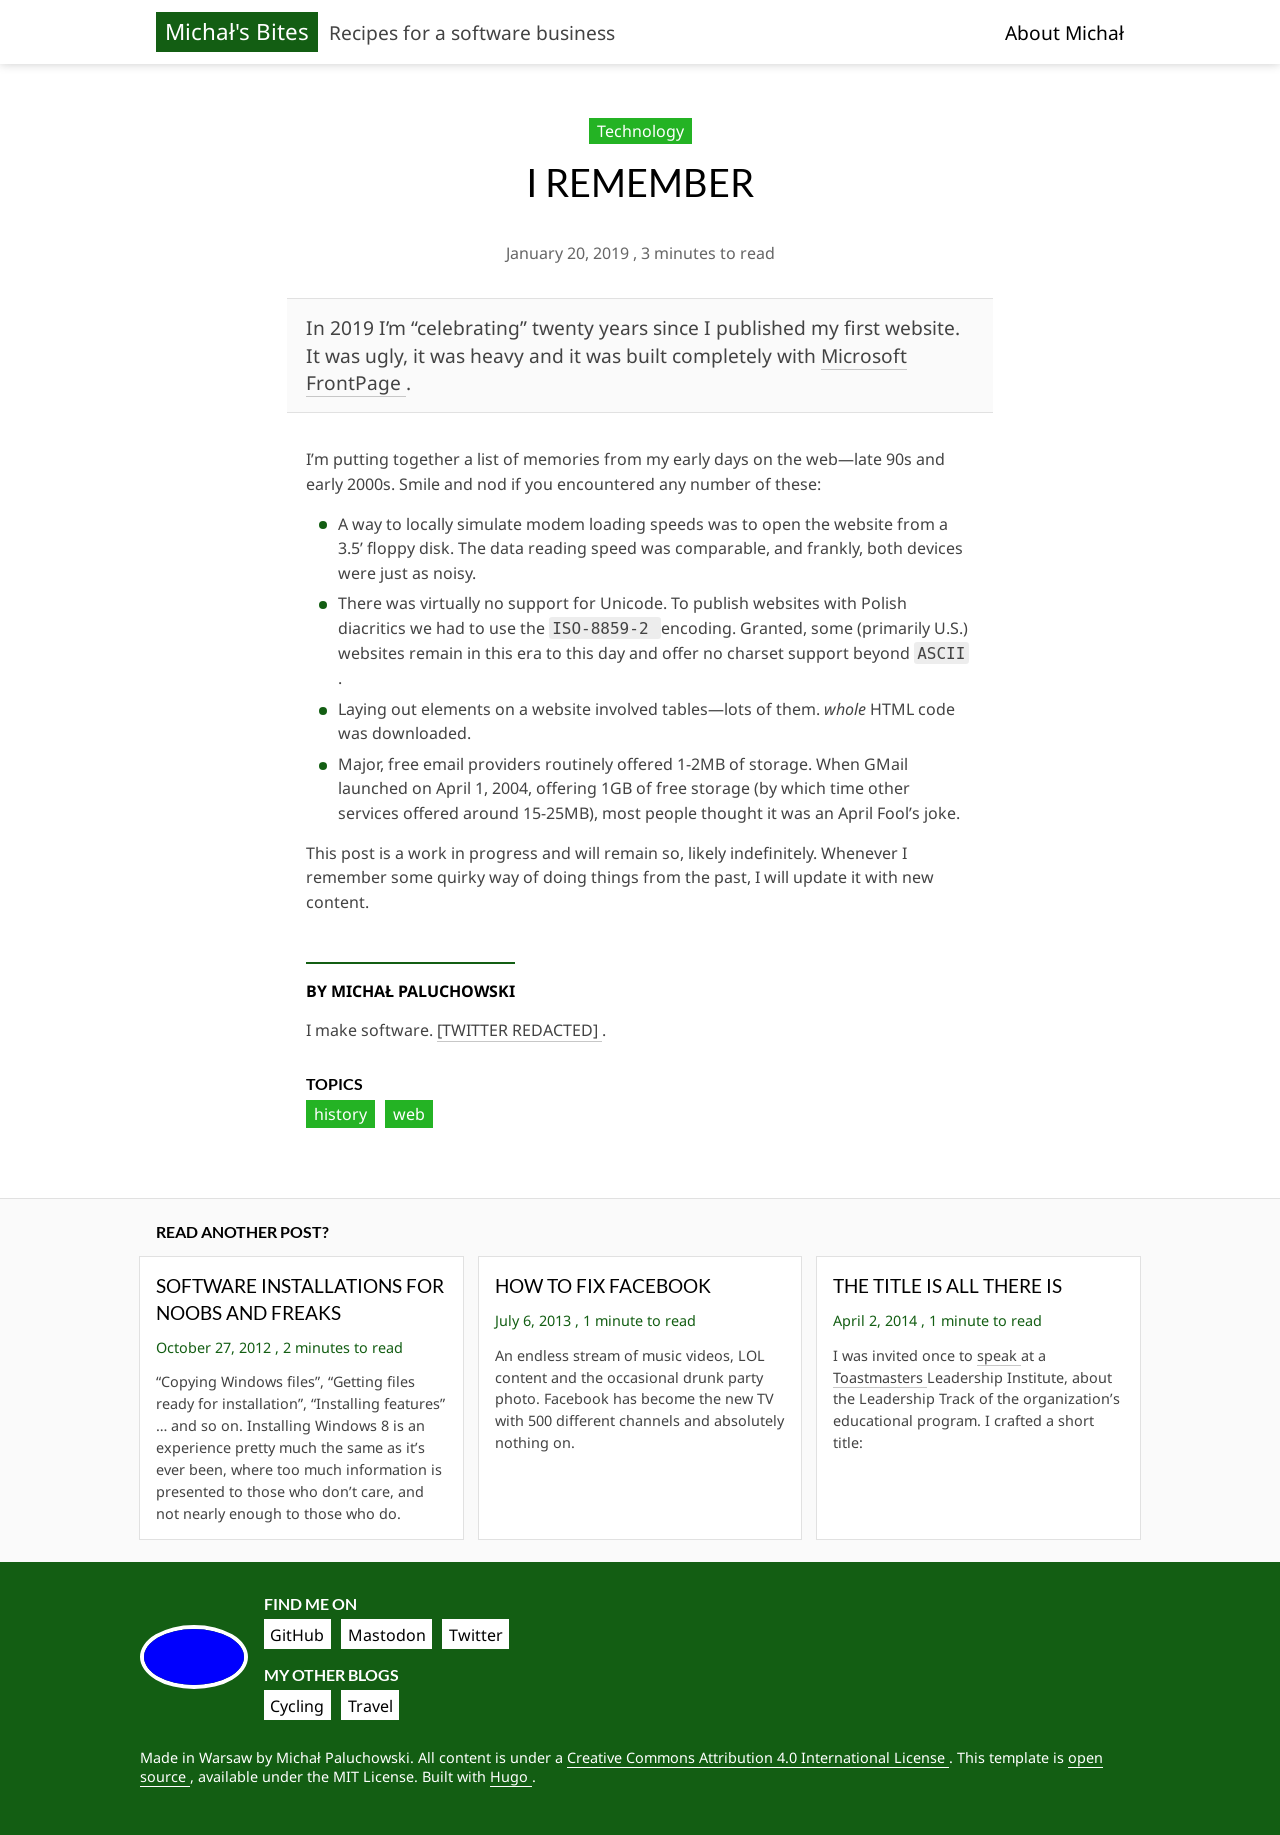Can you describe how the 'Read another post?' section might engage visitors? The 'Read another post?' section engages visitors by prominently displaying links to other blog posts, which can pique their interest and encourage them to explore more content on the site. This feature can help increase the time visitors spend on the website, potentially leading them to become regular readers or followers.  What makes the titles of other posts clickable and appealing? Clickable titles are often succinct and intriguing, providing just enough information to spark curiosity without giving everything away. The use of action-oriented language or posing questions are common tactics to make titles engaging. They are also styled visually to stand out through color, size, or font weight, guiding the visitor's eye directly to them. 